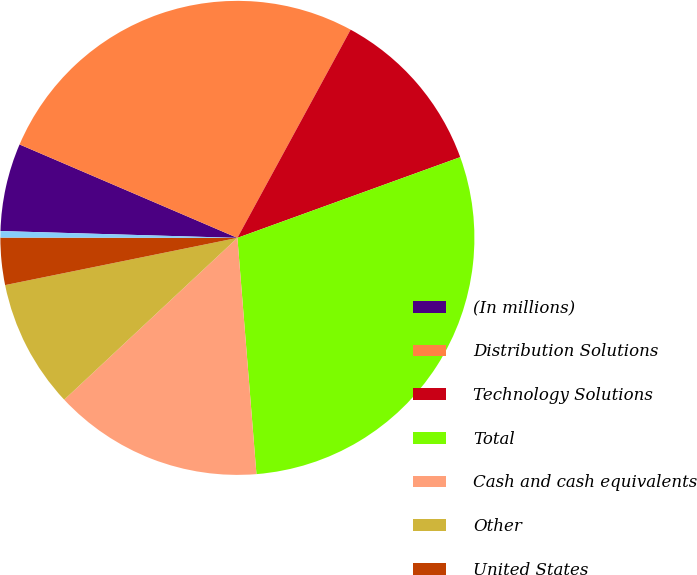<chart> <loc_0><loc_0><loc_500><loc_500><pie_chart><fcel>(In millions)<fcel>Distribution Solutions<fcel>Technology Solutions<fcel>Total<fcel>Cash and cash equivalents<fcel>Other<fcel>United States<fcel>Foreign<nl><fcel>5.99%<fcel>26.48%<fcel>11.54%<fcel>29.25%<fcel>14.32%<fcel>8.77%<fcel>3.21%<fcel>0.44%<nl></chart> 